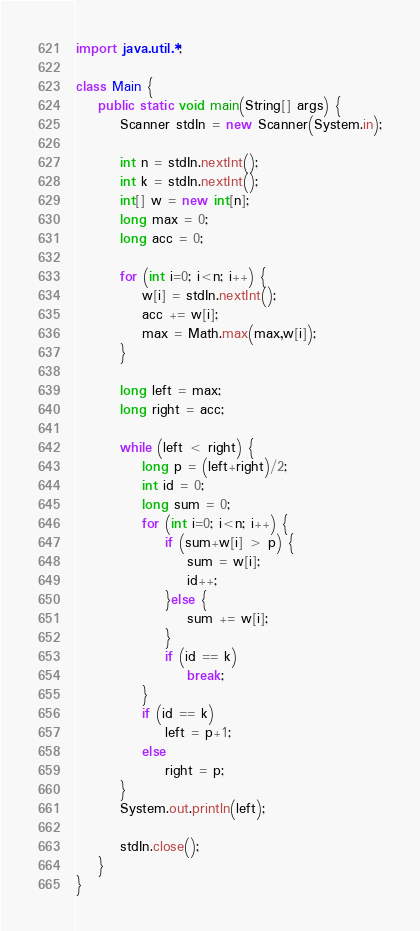Convert code to text. <code><loc_0><loc_0><loc_500><loc_500><_Java_>import java.util.*;
 
class Main {
    public static void main(String[] args) {
        Scanner stdIn = new Scanner(System.in);
 
        int n = stdIn.nextInt();
        int k = stdIn.nextInt();
        int[] w = new int[n];
        long max = 0;
        long acc = 0;
 
        for (int i=0; i<n; i++) {
            w[i] = stdIn.nextInt();
            acc += w[i];
            max = Math.max(max,w[i]);
        }
 
        long left = max;
        long right = acc;
 
        while (left < right) {
            long p = (left+right)/2;
            int id = 0;
            long sum = 0;
            for (int i=0; i<n; i++) {
                if (sum+w[i] > p) {
                    sum = w[i];
                    id++;
                }else {
                    sum += w[i];
                }
                if (id == k)
                    break;
            }
            if (id == k)
                left = p+1;
            else
                right = p;
        }
        System.out.println(left);
 
        stdIn.close();
    }
}

</code> 